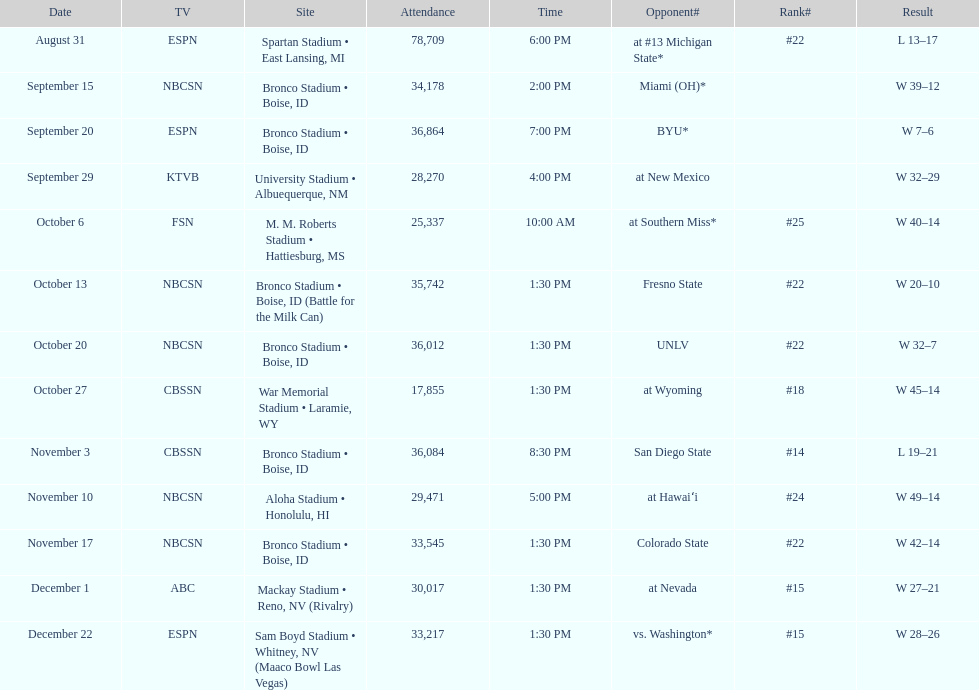Add up the total number of points scored in the last wins for boise state. 146. 